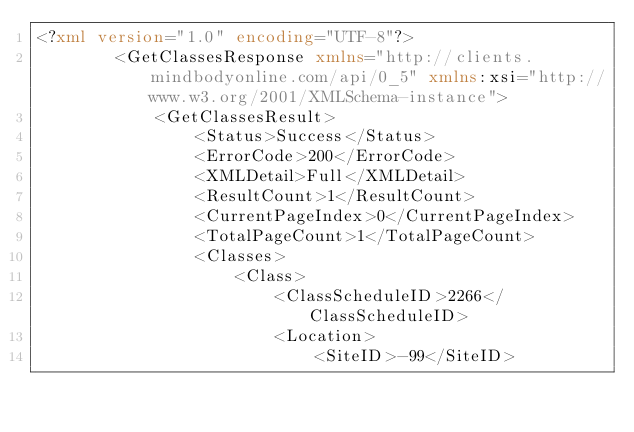Convert code to text. <code><loc_0><loc_0><loc_500><loc_500><_XML_><?xml version="1.0" encoding="UTF-8"?>
        <GetClassesResponse xmlns="http://clients.mindbodyonline.com/api/0_5" xmlns:xsi="http://www.w3.org/2001/XMLSchema-instance">
            <GetClassesResult>
                <Status>Success</Status>
                <ErrorCode>200</ErrorCode>
                <XMLDetail>Full</XMLDetail>
                <ResultCount>1</ResultCount>
                <CurrentPageIndex>0</CurrentPageIndex>
                <TotalPageCount>1</TotalPageCount>
                <Classes>
                    <Class>
                        <ClassScheduleID>2266</ClassScheduleID>
                        <Location>
                            <SiteID>-99</SiteID></code> 